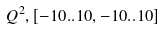Convert formula to latex. <formula><loc_0><loc_0><loc_500><loc_500>Q ^ { 2 } , [ - 1 0 . . 1 0 , - 1 0 . . 1 0 ]</formula> 